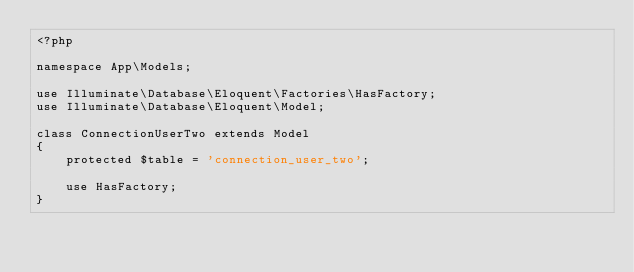Convert code to text. <code><loc_0><loc_0><loc_500><loc_500><_PHP_><?php

namespace App\Models;

use Illuminate\Database\Eloquent\Factories\HasFactory;
use Illuminate\Database\Eloquent\Model;

class ConnectionUserTwo extends Model
{
    protected $table = 'connection_user_two';
    
    use HasFactory;
}
</code> 